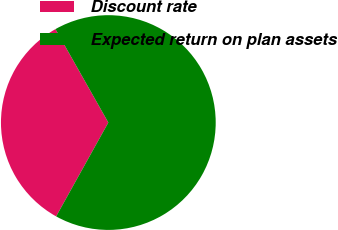<chart> <loc_0><loc_0><loc_500><loc_500><pie_chart><fcel>Discount rate<fcel>Expected return on plan assets<nl><fcel>33.73%<fcel>66.27%<nl></chart> 